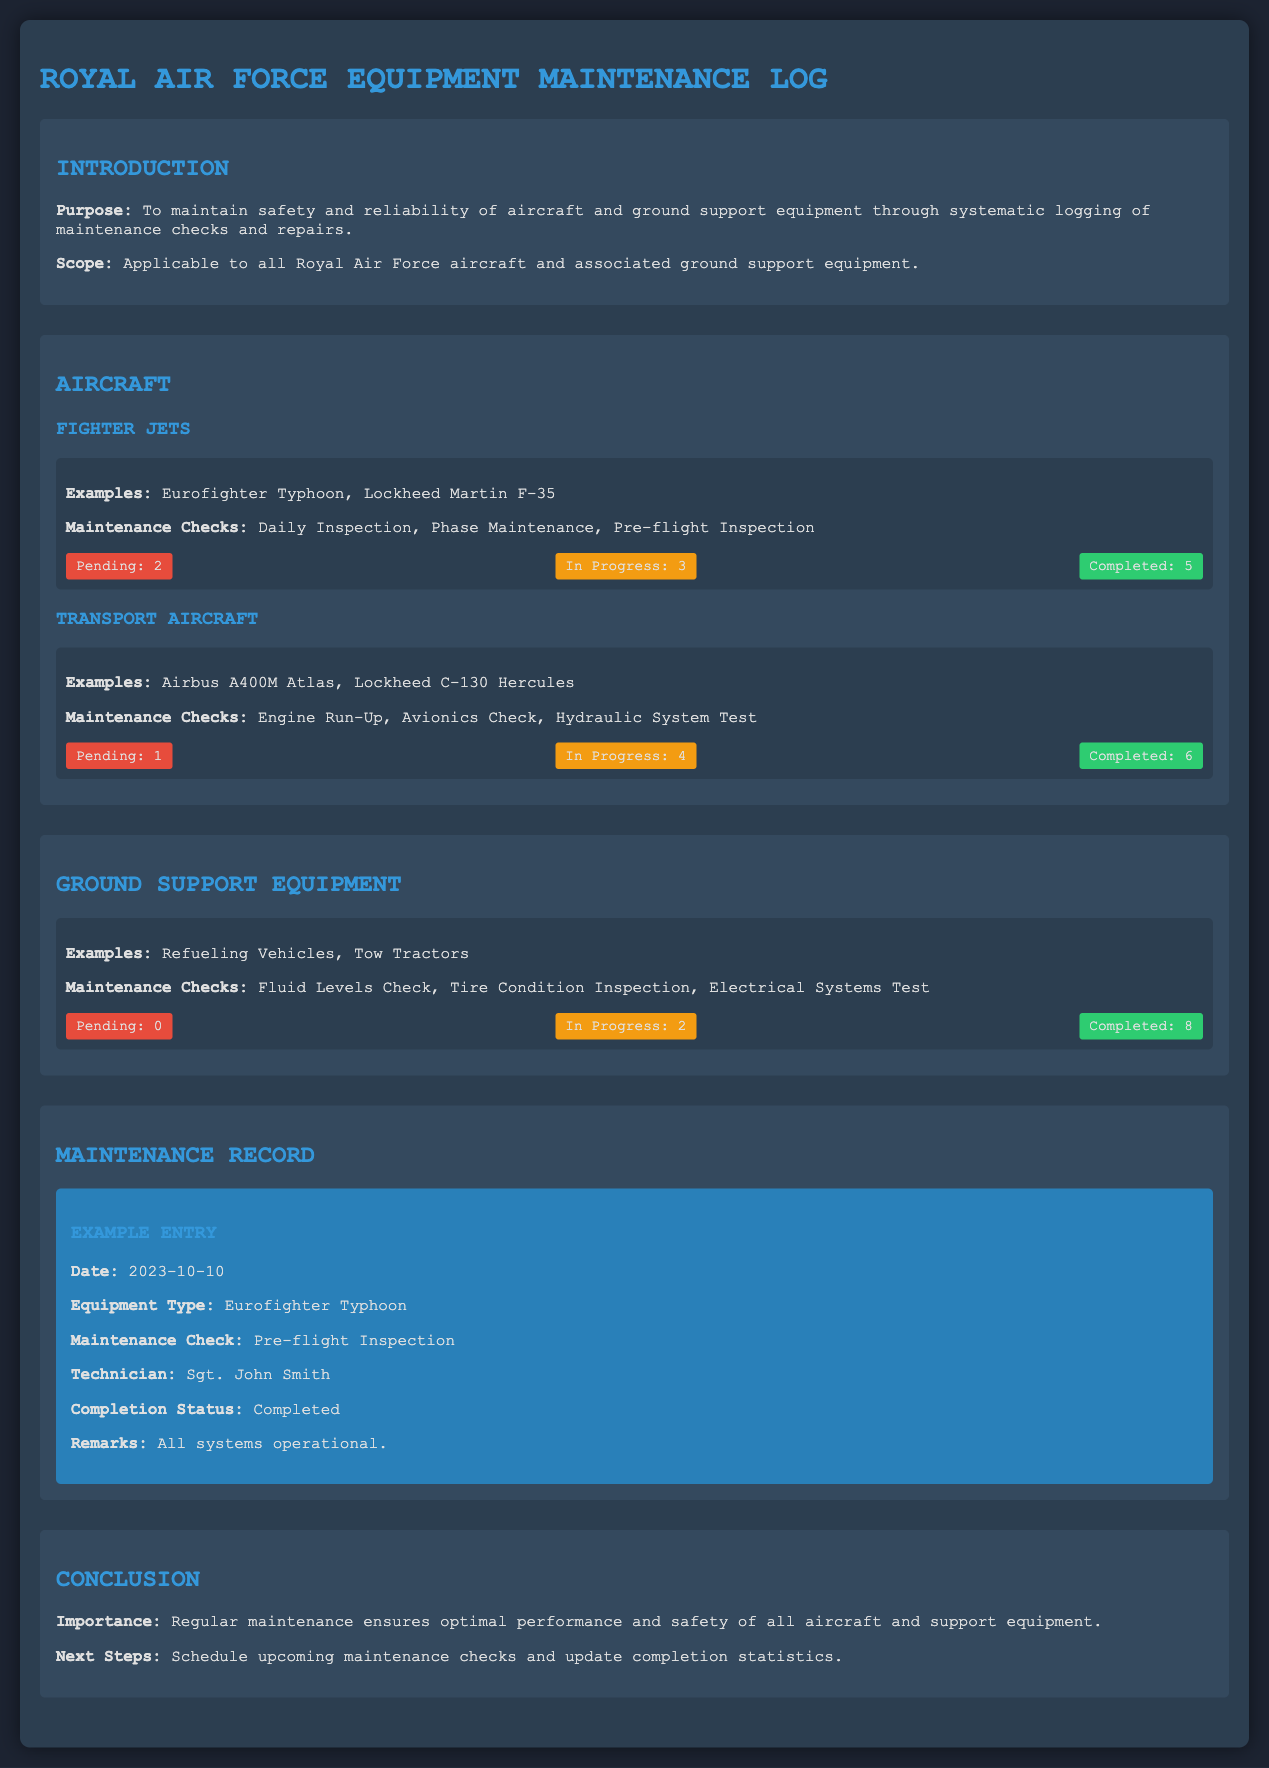What is the purpose of the Equipment Maintenance Log? The purpose is to maintain safety and reliability of aircraft and ground support equipment through systematic logging of maintenance checks and repairs.
Answer: To maintain safety and reliability How many completed maintenance checks are there for Fighter Jets? The total completed maintenance checks for Fighter Jets is listed as 5 in the document.
Answer: 5 What type of aircraft is the Lockheed Martin F-35? The Lockheed Martin F-35 is categorized under Fighter Jets in the document.
Answer: Fighter Jets What is the completion status of the maintenance checks for Ground Support Equipment? The completion status shows 8 completed maintenance checks for Ground Support Equipment.
Answer: 8 Who was the technician for the example entry? The technician listed in the example entry is Sgt. John Smith.
Answer: Sgt. John Smith How many maintenance checks are pending for Transport Aircraft? There is 1 pending maintenance check for Transport Aircraft according to the document.
Answer: 1 What maintenance check is associated with the Eurofighter Typhoon? The maintenance check associated with the Eurofighter Typhoon is the Pre-flight Inspection.
Answer: Pre-flight Inspection What is the status of maintenance checks for Ground Support Equipment? The status indicates that there are 0 pending, 2 in progress, and 8 completed checks.
Answer: 0 pending, 2 in progress, 8 completed How often are daily inspections performed on Fighter Jets? The document mentions that Daily Inspections are part of the maintenance checks for Fighter Jets, but does not specify frequency.
Answer: Not specified 